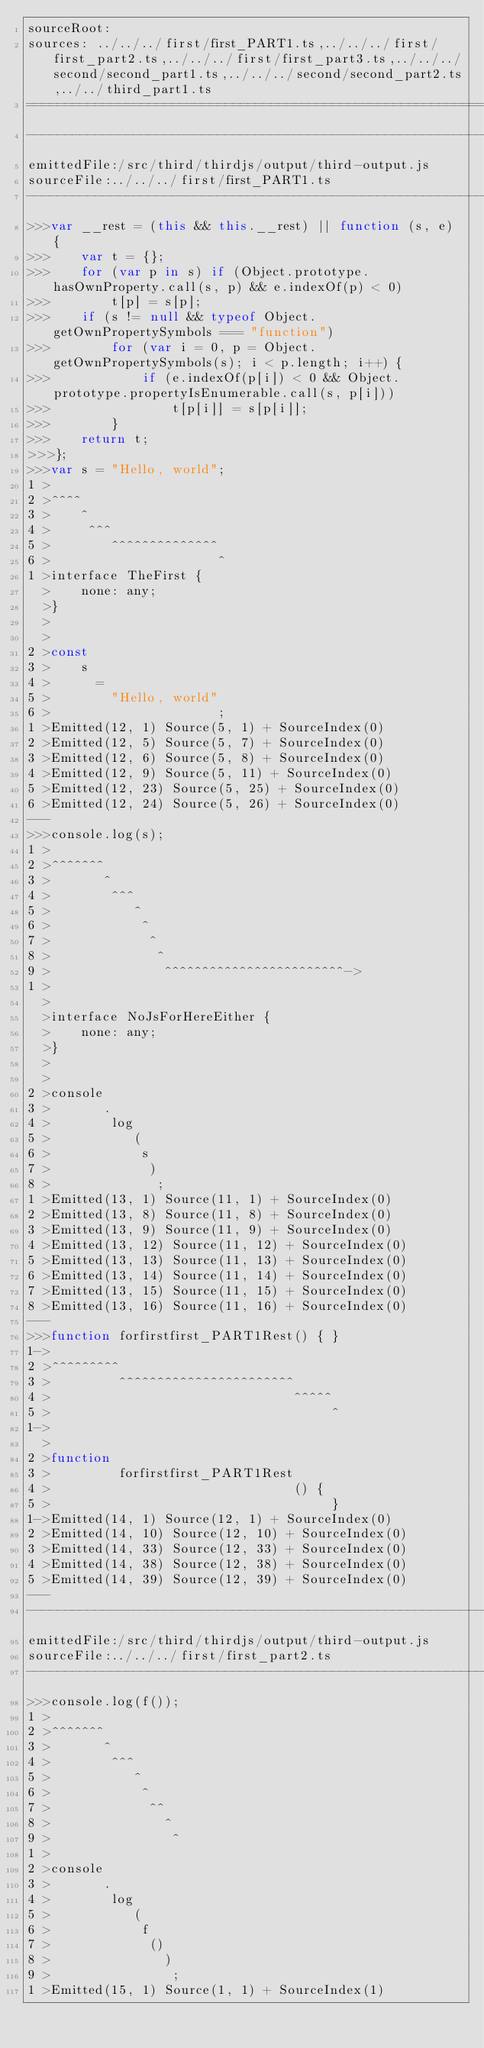<code> <loc_0><loc_0><loc_500><loc_500><_JavaScript_>sourceRoot: 
sources: ../../../first/first_PART1.ts,../../../first/first_part2.ts,../../../first/first_part3.ts,../../../second/second_part1.ts,../../../second/second_part2.ts,../../third_part1.ts
===================================================================
-------------------------------------------------------------------
emittedFile:/src/third/thirdjs/output/third-output.js
sourceFile:../../../first/first_PART1.ts
-------------------------------------------------------------------
>>>var __rest = (this && this.__rest) || function (s, e) {
>>>    var t = {};
>>>    for (var p in s) if (Object.prototype.hasOwnProperty.call(s, p) && e.indexOf(p) < 0)
>>>        t[p] = s[p];
>>>    if (s != null && typeof Object.getOwnPropertySymbols === "function")
>>>        for (var i = 0, p = Object.getOwnPropertySymbols(s); i < p.length; i++) {
>>>            if (e.indexOf(p[i]) < 0 && Object.prototype.propertyIsEnumerable.call(s, p[i]))
>>>                t[p[i]] = s[p[i]];
>>>        }
>>>    return t;
>>>};
>>>var s = "Hello, world";
1 >
2 >^^^^
3 >    ^
4 >     ^^^
5 >        ^^^^^^^^^^^^^^
6 >                      ^
1 >interface TheFirst {
  >    none: any;
  >}
  >
  >
2 >const 
3 >    s
4 >      = 
5 >        "Hello, world"
6 >                      ;
1 >Emitted(12, 1) Source(5, 1) + SourceIndex(0)
2 >Emitted(12, 5) Source(5, 7) + SourceIndex(0)
3 >Emitted(12, 6) Source(5, 8) + SourceIndex(0)
4 >Emitted(12, 9) Source(5, 11) + SourceIndex(0)
5 >Emitted(12, 23) Source(5, 25) + SourceIndex(0)
6 >Emitted(12, 24) Source(5, 26) + SourceIndex(0)
---
>>>console.log(s);
1 >
2 >^^^^^^^
3 >       ^
4 >        ^^^
5 >           ^
6 >            ^
7 >             ^
8 >              ^
9 >               ^^^^^^^^^^^^^^^^^^^^^^^^->
1 >
  >
  >interface NoJsForHereEither {
  >    none: any;
  >}
  >
  >
2 >console
3 >       .
4 >        log
5 >           (
6 >            s
7 >             )
8 >              ;
1 >Emitted(13, 1) Source(11, 1) + SourceIndex(0)
2 >Emitted(13, 8) Source(11, 8) + SourceIndex(0)
3 >Emitted(13, 9) Source(11, 9) + SourceIndex(0)
4 >Emitted(13, 12) Source(11, 12) + SourceIndex(0)
5 >Emitted(13, 13) Source(11, 13) + SourceIndex(0)
6 >Emitted(13, 14) Source(11, 14) + SourceIndex(0)
7 >Emitted(13, 15) Source(11, 15) + SourceIndex(0)
8 >Emitted(13, 16) Source(11, 16) + SourceIndex(0)
---
>>>function forfirstfirst_PART1Rest() { }
1->
2 >^^^^^^^^^
3 >         ^^^^^^^^^^^^^^^^^^^^^^^
4 >                                ^^^^^
5 >                                     ^
1->
  >
2 >function 
3 >         forfirstfirst_PART1Rest
4 >                                () { 
5 >                                     }
1->Emitted(14, 1) Source(12, 1) + SourceIndex(0)
2 >Emitted(14, 10) Source(12, 10) + SourceIndex(0)
3 >Emitted(14, 33) Source(12, 33) + SourceIndex(0)
4 >Emitted(14, 38) Source(12, 38) + SourceIndex(0)
5 >Emitted(14, 39) Source(12, 39) + SourceIndex(0)
---
-------------------------------------------------------------------
emittedFile:/src/third/thirdjs/output/third-output.js
sourceFile:../../../first/first_part2.ts
-------------------------------------------------------------------
>>>console.log(f());
1 >
2 >^^^^^^^
3 >       ^
4 >        ^^^
5 >           ^
6 >            ^
7 >             ^^
8 >               ^
9 >                ^
1 >
2 >console
3 >       .
4 >        log
5 >           (
6 >            f
7 >             ()
8 >               )
9 >                ;
1 >Emitted(15, 1) Source(1, 1) + SourceIndex(1)</code> 